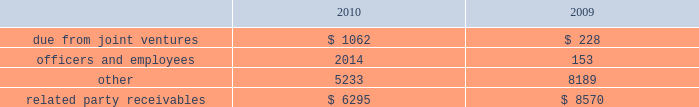Amounts due from related parties at december a031 , 2010 and 2009 con- sisted of the following ( in thousands ) : .
Gramercy capital corp .
See note a0 6 , 201cinvestment in unconsolidated joint ventures 2014gramercy capital corp. , 201d for disclosure on related party transactions between gramercy and the company .
13 2002equit y common stock our authorized capital stock consists of 260000000 shares , $ .01 par value , of which we have authorized the issuance of up to 160000000 shares of common stock , $ .01 par value per share , 75000000 shares of excess stock , $ .01 par value per share , and 25000000 shares of preferred stock , $ .01 par value per share .
As of december a031 , 2010 , 78306702 shares of common stock and no shares of excess stock were issued and outstanding .
In may 2009 , we sold 19550000 shares of our common stock at a gross price of $ 20.75 per share .
The net proceeds from this offer- ing ( approximately $ 387.1 a0 million ) were primarily used to repurchase unsecured debt .
Perpetual preferred stock in january 2010 , we sold 5400000 shares of our series a0c preferred stock in an underwritten public offering .
As a result of this offering , we have 11700000 shares of the series a0 c preferred stock outstanding .
The shares of series a0c preferred stock have a liquidation preference of $ 25.00 per share and are redeemable at par , plus accrued and unpaid dividends , at any time at our option .
The shares were priced at $ 23.53 per share including accrued dividends equating to a yield of 8.101% ( 8.101 % ) .
We used the net offering proceeds of approximately $ 122.0 a0million for gen- eral corporate and/or working capital purposes , including purchases of the indebtedness of our subsidiaries and investment opportunities .
In december 2003 , we sold 6300000 shares of our 7.625% ( 7.625 % ) series a0 c preferred stock , ( including the underwriters 2019 over-allotment option of 700000 shares ) with a mandatory liquidation preference of $ 25.00 per share .
Net proceeds from this offering ( approximately $ 152.0 a0 million ) were used principally to repay amounts outstanding under our secured and unsecured revolving credit facilities .
The series a0c preferred stockholders receive annual dividends of $ 1.90625 per share paid on a quarterly basis and dividends are cumulative , subject to cer- tain provisions .
Since december a0 12 , 2008 , we have been entitled to redeem the series a0c preferred stock at par for cash at our option .
The series a0c preferred stock was recorded net of underwriters discount and issuance costs .
12 2002related part y transactions cleaning/securit y/messenger and restoration services through al l iance bui lding services , or al l iance , first qual i t y maintenance , a0l.p. , or first quality , provides cleaning , extermination and related services , classic security a0llc provides security services , bright star couriers a0llc provides messenger services , and onyx restoration works provides restoration services with respect to certain proper- ties owned by us .
Alliance is partially owned by gary green , a son of stephen a0l .
Green , the chairman of our board of directors .
In addition , first quality has the non-exclusive opportunity to provide cleaning and related services to individual tenants at our properties on a basis sepa- rately negotiated with any tenant seeking such additional services .
The service corp .
Has entered into an arrangement with alliance whereby it will receive a profit participation above a certain threshold for services provided by alliance to certain tenants at certain buildings above the base services specified in their lease agreements .
Alliance paid the service corporation approximately $ 2.2 a0million , $ 1.8 a0million and $ 1.4 a0million for the years ended december a031 , 2010 , 2009 and 2008 , respectively .
We paid alliance approximately $ 14.2 a0million , $ 14.9 a0million and $ 15.1 a0million for three years ended december a031 , 2010 , respectively , for these ser- vices ( excluding services provided directly to tenants ) .
Leases nancy peck and company leases 1003 square feet of space at 420 lexington avenue under a lease that ends in august 2015 .
Nancy peck and company is owned by nancy peck , the wife of stephen a0l .
Green .
The rent due pursuant to the lease is $ 35516 per annum for year one increas- ing to $ 40000 in year seven .
From february 2007 through december 2008 , nancy peck and company leased 507 square feet of space at 420 a0 lexington avenue pursuant to a lease which provided for annual rental payments of approximately $ 15210 .
Brokerage services cushman a0 & wakefield sonnenblick-goldman , a0 llc , or sonnenblick , a nationally recognized real estate investment banking firm , provided mortgage brokerage services to us .
Mr . a0 morton holliday , the father of mr . a0 marc holliday , was a managing director of sonnenblick at the time of the financings .
In 2009 , we paid approximately $ 428000 to sonnenblick in connection with the purchase of a sub-leasehold interest and the refinancing of 420 lexington avenue .
Management fees s.l .
Green management corp. , a consolidated entity , receives property management fees from an entity in which stephen a0l .
Green owns an inter- est .
The aggregate amount of fees paid to s.l .
Green management corp .
From such entity was approximately $ 390700 in 2010 , $ 351700 in 2009 and $ 353500 in 2008 .
Notes to consolidated financial statements .
For the shares of series c preferred stock priced at $ 23.53 per share , what was the yield in dollars including accrued dividends? 
Computations: (23.53 * 8.101%)
Answer: 1.90617. 